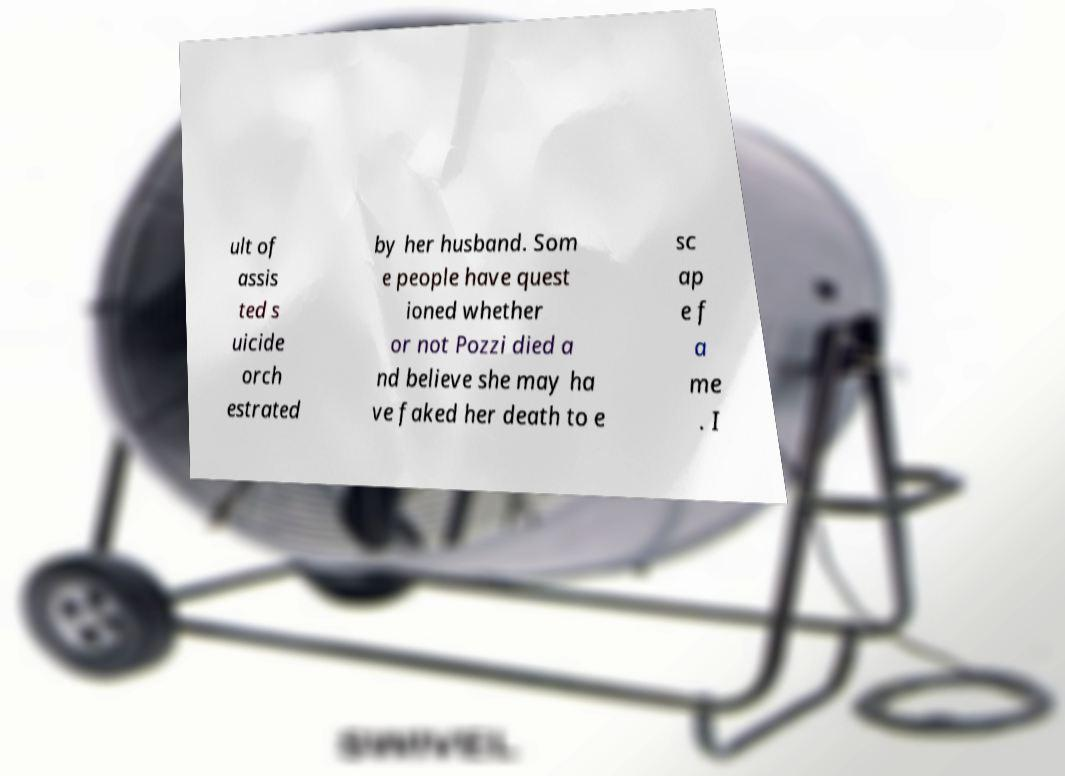What messages or text are displayed in this image? I need them in a readable, typed format. ult of assis ted s uicide orch estrated by her husband. Som e people have quest ioned whether or not Pozzi died a nd believe she may ha ve faked her death to e sc ap e f a me . I 